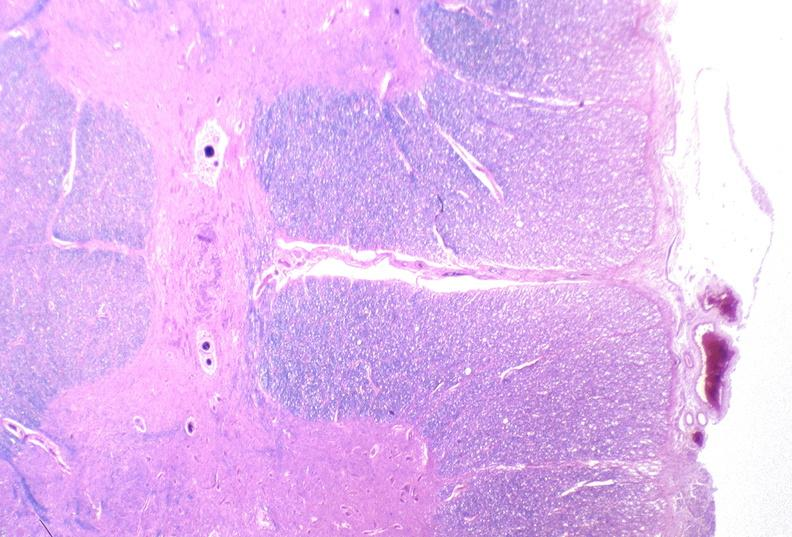does soft tissue show spinal cord injury due to vertebral column trauma, demyelination?
Answer the question using a single word or phrase. No 